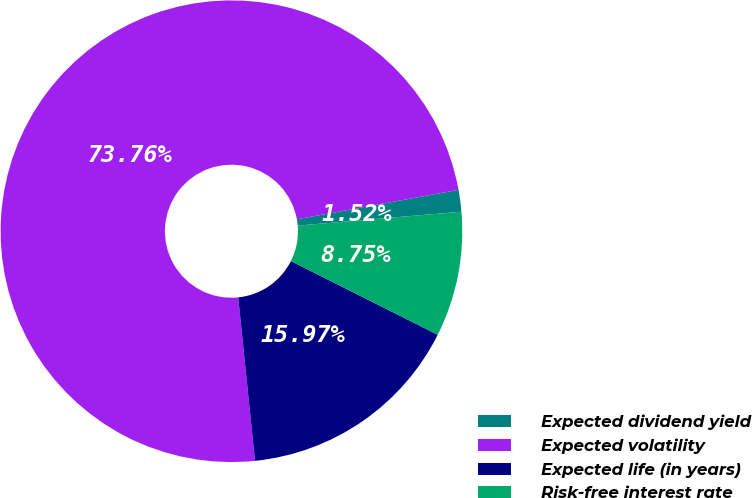<chart> <loc_0><loc_0><loc_500><loc_500><pie_chart><fcel>Expected dividend yield<fcel>Expected volatility<fcel>Expected life (in years)<fcel>Risk-free interest rate<nl><fcel>1.52%<fcel>73.76%<fcel>15.97%<fcel>8.75%<nl></chart> 